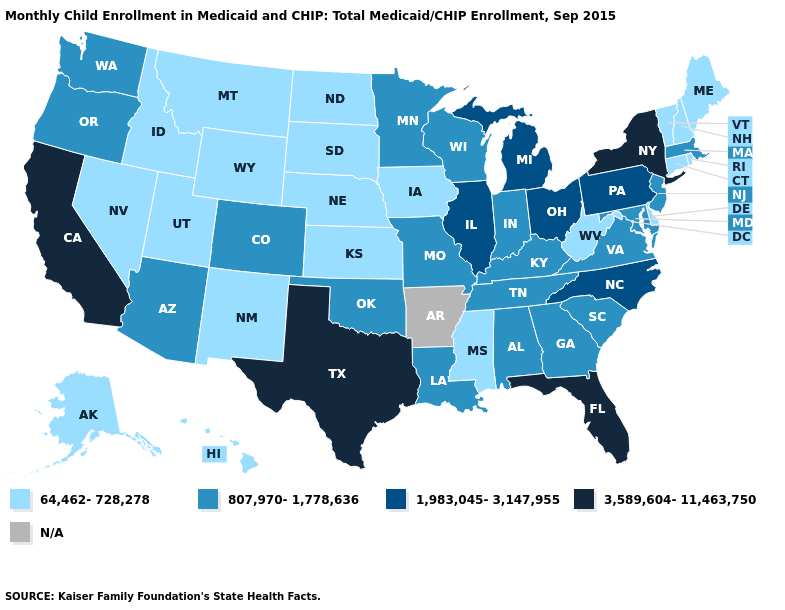What is the lowest value in states that border Idaho?
Be succinct. 64,462-728,278. Which states have the lowest value in the MidWest?
Keep it brief. Iowa, Kansas, Nebraska, North Dakota, South Dakota. Among the states that border Michigan , does Ohio have the highest value?
Short answer required. Yes. Name the states that have a value in the range N/A?
Write a very short answer. Arkansas. Does Pennsylvania have the highest value in the USA?
Be succinct. No. Name the states that have a value in the range 64,462-728,278?
Write a very short answer. Alaska, Connecticut, Delaware, Hawaii, Idaho, Iowa, Kansas, Maine, Mississippi, Montana, Nebraska, Nevada, New Hampshire, New Mexico, North Dakota, Rhode Island, South Dakota, Utah, Vermont, West Virginia, Wyoming. Name the states that have a value in the range 64,462-728,278?
Keep it brief. Alaska, Connecticut, Delaware, Hawaii, Idaho, Iowa, Kansas, Maine, Mississippi, Montana, Nebraska, Nevada, New Hampshire, New Mexico, North Dakota, Rhode Island, South Dakota, Utah, Vermont, West Virginia, Wyoming. What is the lowest value in the USA?
Be succinct. 64,462-728,278. What is the value of Washington?
Quick response, please. 807,970-1,778,636. Among the states that border California , which have the lowest value?
Quick response, please. Nevada. Name the states that have a value in the range 807,970-1,778,636?
Answer briefly. Alabama, Arizona, Colorado, Georgia, Indiana, Kentucky, Louisiana, Maryland, Massachusetts, Minnesota, Missouri, New Jersey, Oklahoma, Oregon, South Carolina, Tennessee, Virginia, Washington, Wisconsin. Among the states that border Delaware , which have the highest value?
Give a very brief answer. Pennsylvania. What is the value of Georgia?
Keep it brief. 807,970-1,778,636. What is the value of Rhode Island?
Concise answer only. 64,462-728,278. What is the lowest value in the USA?
Concise answer only. 64,462-728,278. 